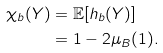Convert formula to latex. <formula><loc_0><loc_0><loc_500><loc_500>\chi _ { b } ( Y ) & = \mathbb { E } [ h _ { b } ( Y ) ] \\ & = 1 - 2 \mu _ { B } ( 1 ) .</formula> 